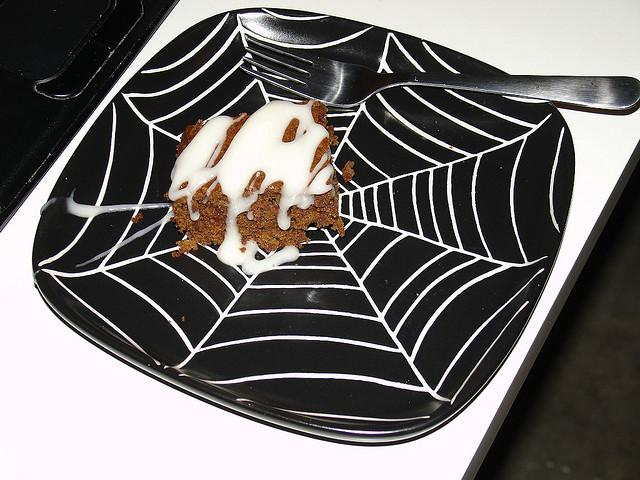What design is painted onto the plate? Please explain your reasoning. spider web. A black plate has white stretched across it in a geometric pattern. 